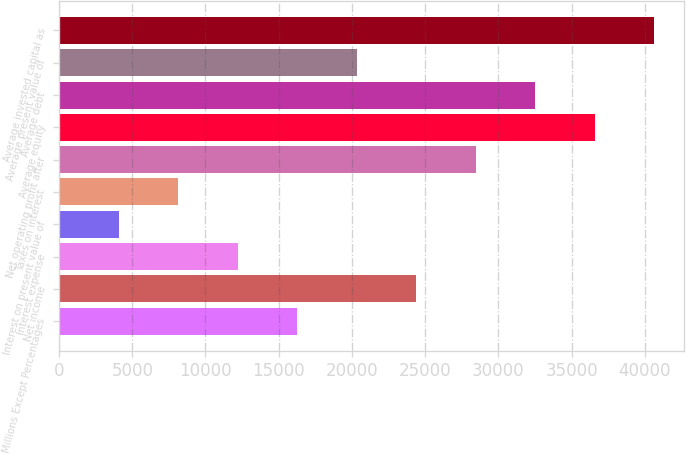Convert chart to OTSL. <chart><loc_0><loc_0><loc_500><loc_500><bar_chart><fcel>Millions Except Percentages<fcel>Net income<fcel>Interest expense<fcel>Interest on present value of<fcel>Taxes on interest<fcel>Net operating profit after<fcel>Average equity<fcel>Average debt<fcel>Average present value of<fcel>Average invested capital as<nl><fcel>16279.8<fcel>24405.8<fcel>12216.7<fcel>4090.64<fcel>8153.68<fcel>28468.9<fcel>36595<fcel>32531.9<fcel>20342.8<fcel>40658<nl></chart> 